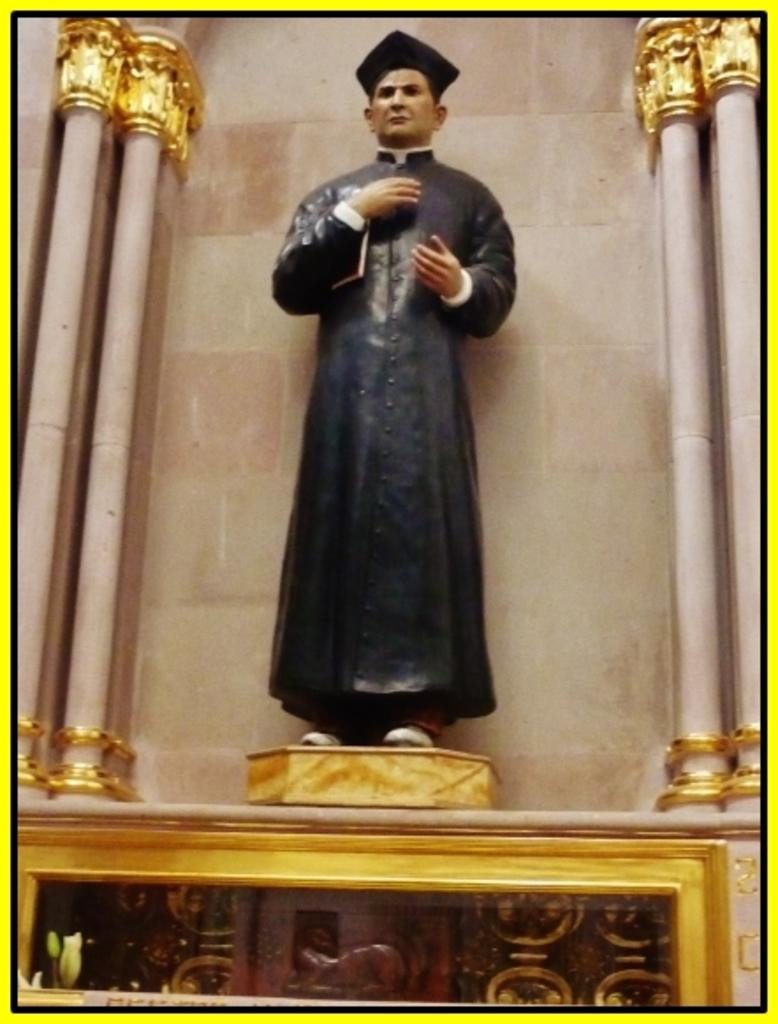What is the main subject in the image? There is a statue in the image. What architectural features can be seen on the right side of the image? There are pillars on the right side of the image. What architectural features can be seen on the left side of the image? There are pillars on the left side of the image. What type of wall can be seen behind the statue in the image? There is no wall visible behind the statue in the image. What type of star can be seen interacting with the statue in the image? There is no star present in the image. 